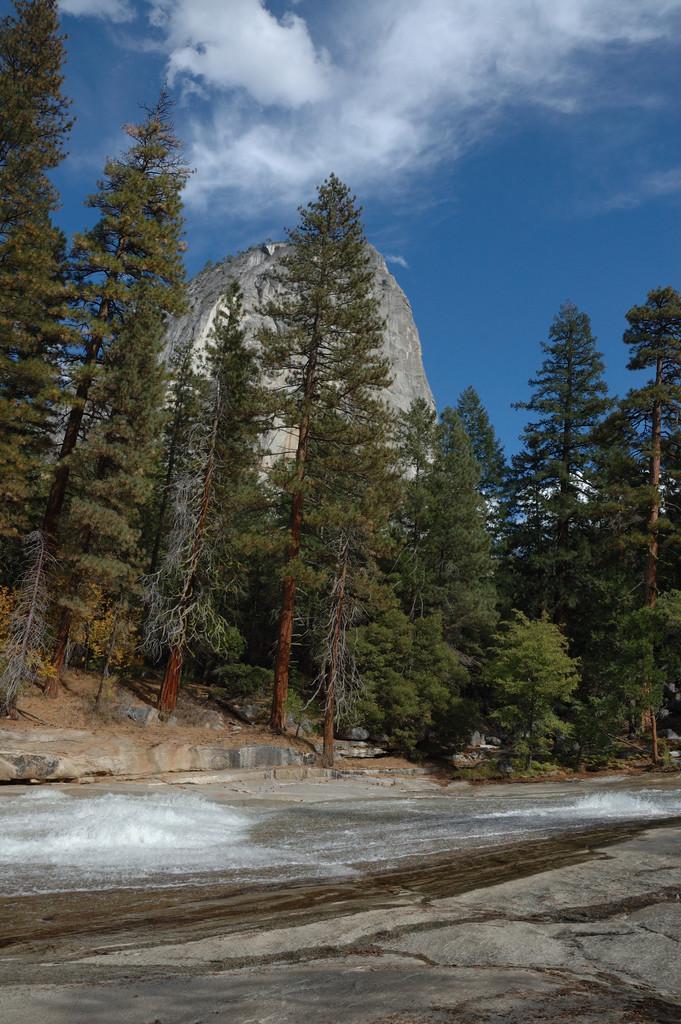In one or two sentences, can you explain what this image depicts? In this image we can see a group of trees, the mountain and the sky which looks cloudy. On the bottom of the image we can see some snow and water on the ground. 